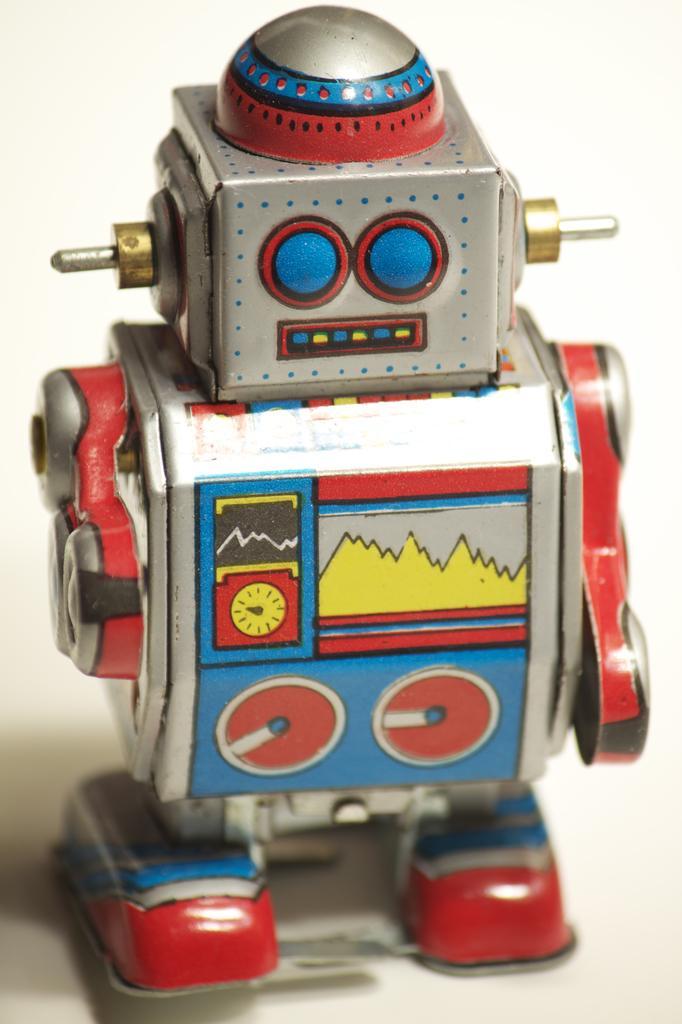Describe this image in one or two sentences. In this image there is robot toy in middle of this image. 